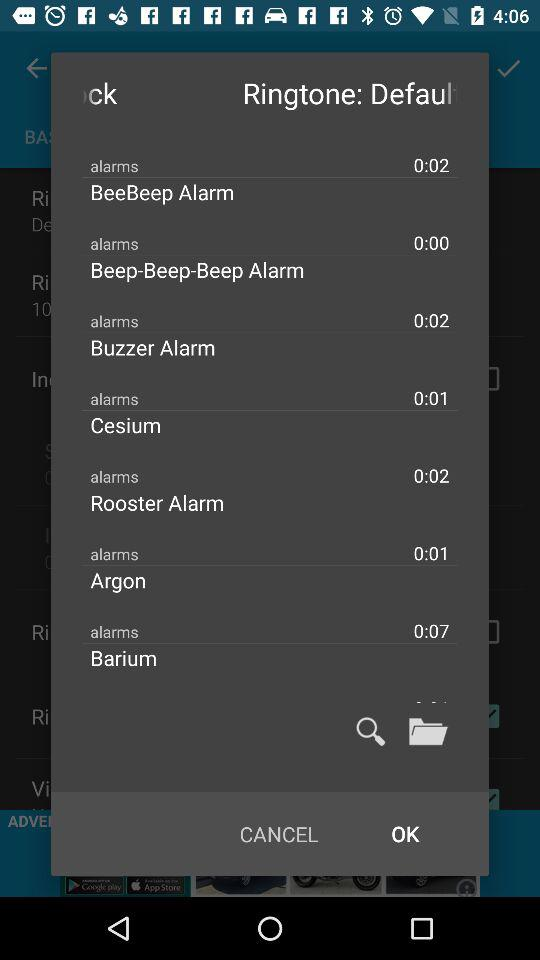How long is the BeeBeep alarm? The BeeBeep alarm is 2 seconds long. 